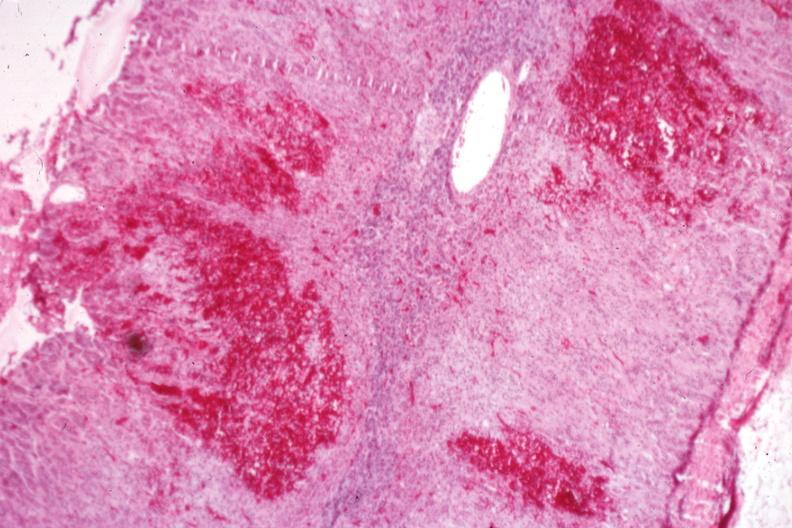what does this image show?
Answer the question using a single word or phrase. Multiple cortical hemorrhages which may be the early stage of a gross adrenal hemorrhage 